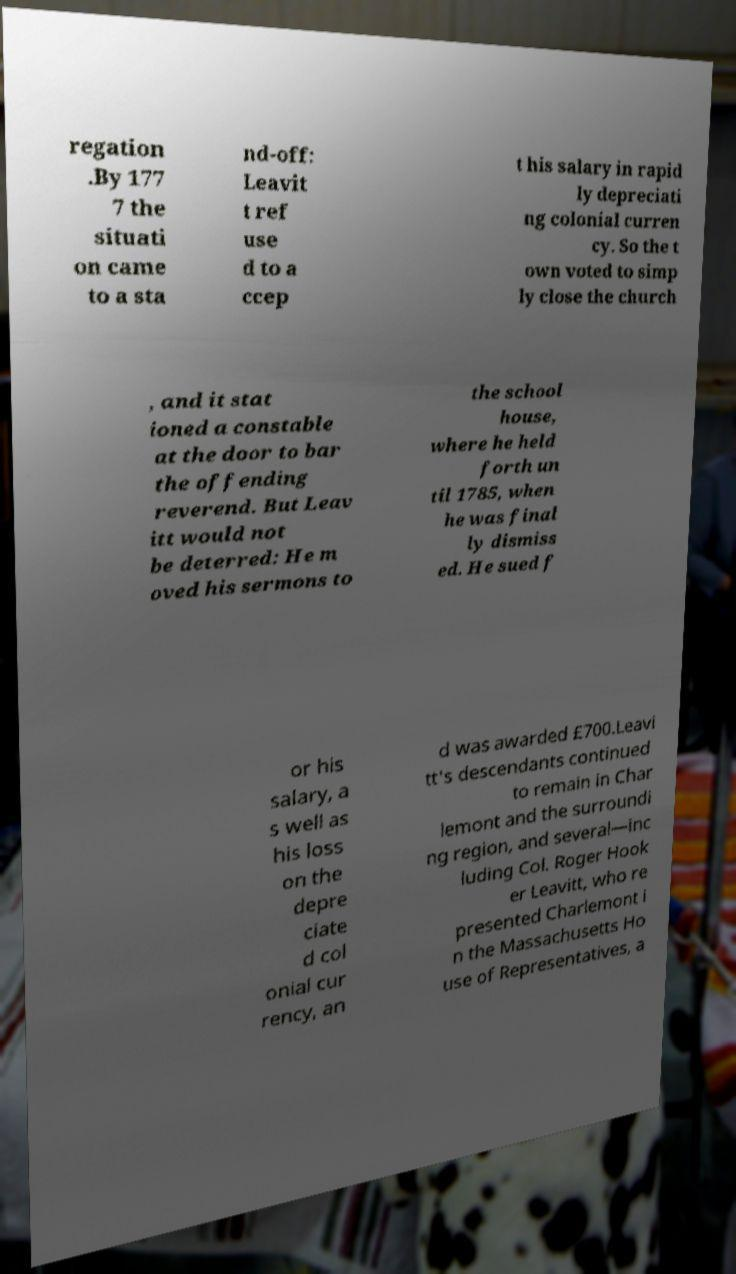I need the written content from this picture converted into text. Can you do that? regation .By 177 7 the situati on came to a sta nd-off: Leavit t ref use d to a ccep t his salary in rapid ly depreciati ng colonial curren cy. So the t own voted to simp ly close the church , and it stat ioned a constable at the door to bar the offending reverend. But Leav itt would not be deterred: He m oved his sermons to the school house, where he held forth un til 1785, when he was final ly dismiss ed. He sued f or his salary, a s well as his loss on the depre ciate d col onial cur rency, an d was awarded £700.Leavi tt's descendants continued to remain in Char lemont and the surroundi ng region, and several—inc luding Col. Roger Hook er Leavitt, who re presented Charlemont i n the Massachusetts Ho use of Representatives, a 